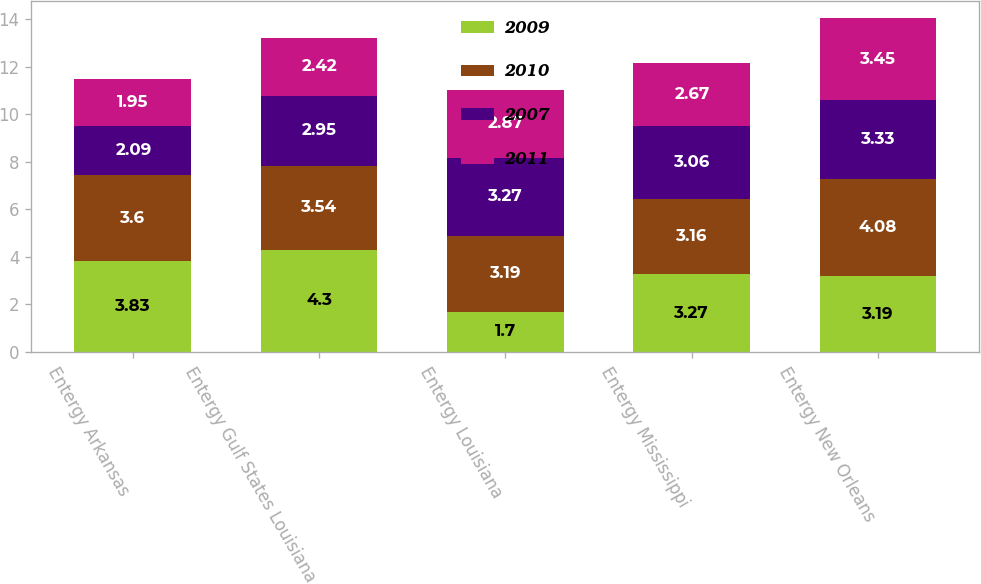Convert chart to OTSL. <chart><loc_0><loc_0><loc_500><loc_500><stacked_bar_chart><ecel><fcel>Entergy Arkansas<fcel>Entergy Gulf States Louisiana<fcel>Entergy Louisiana<fcel>Entergy Mississippi<fcel>Entergy New Orleans<nl><fcel>2009<fcel>3.83<fcel>4.3<fcel>1.7<fcel>3.27<fcel>3.19<nl><fcel>2010<fcel>3.6<fcel>3.54<fcel>3.19<fcel>3.16<fcel>4.08<nl><fcel>2007<fcel>2.09<fcel>2.95<fcel>3.27<fcel>3.06<fcel>3.33<nl><fcel>2011<fcel>1.95<fcel>2.42<fcel>2.87<fcel>2.67<fcel>3.45<nl></chart> 